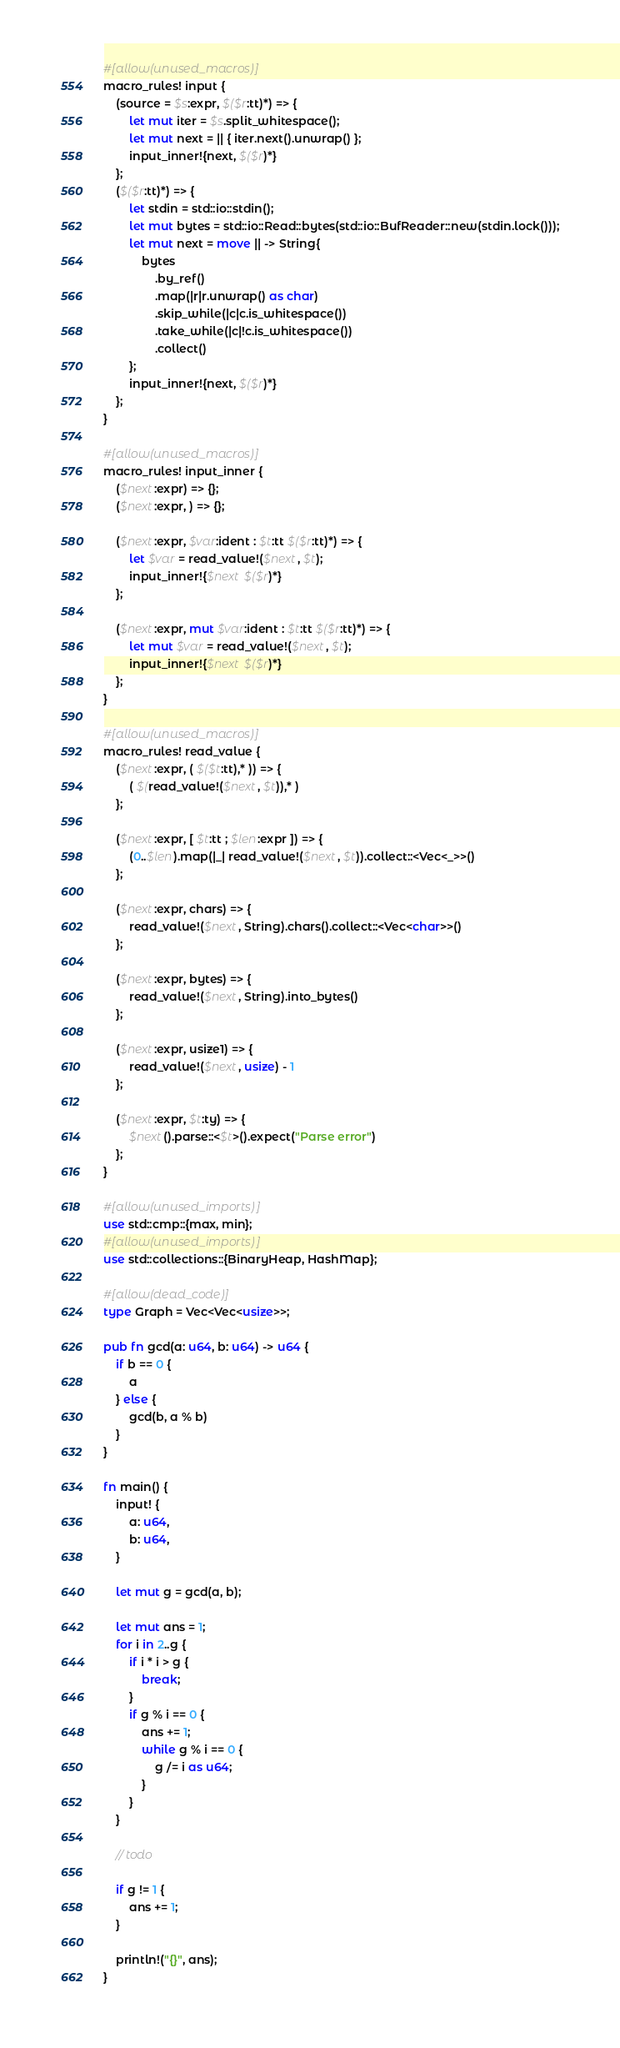Convert code to text. <code><loc_0><loc_0><loc_500><loc_500><_Rust_>#[allow(unused_macros)]
macro_rules! input {
    (source = $s:expr, $($r:tt)*) => {
        let mut iter = $s.split_whitespace();
        let mut next = || { iter.next().unwrap() };
        input_inner!{next, $($r)*}
    };
    ($($r:tt)*) => {
        let stdin = std::io::stdin();
        let mut bytes = std::io::Read::bytes(std::io::BufReader::new(stdin.lock()));
        let mut next = move || -> String{
            bytes
                .by_ref()
                .map(|r|r.unwrap() as char)
                .skip_while(|c|c.is_whitespace())
                .take_while(|c|!c.is_whitespace())
                .collect()
        };
        input_inner!{next, $($r)*}
    };
}

#[allow(unused_macros)]
macro_rules! input_inner {
    ($next:expr) => {};
    ($next:expr, ) => {};

    ($next:expr, $var:ident : $t:tt $($r:tt)*) => {
        let $var = read_value!($next, $t);
        input_inner!{$next $($r)*}
    };

    ($next:expr, mut $var:ident : $t:tt $($r:tt)*) => {
        let mut $var = read_value!($next, $t);
        input_inner!{$next $($r)*}
    };
}

#[allow(unused_macros)]
macro_rules! read_value {
    ($next:expr, ( $($t:tt),* )) => {
        ( $(read_value!($next, $t)),* )
    };

    ($next:expr, [ $t:tt ; $len:expr ]) => {
        (0..$len).map(|_| read_value!($next, $t)).collect::<Vec<_>>()
    };

    ($next:expr, chars) => {
        read_value!($next, String).chars().collect::<Vec<char>>()
    };

    ($next:expr, bytes) => {
        read_value!($next, String).into_bytes()
    };

    ($next:expr, usize1) => {
        read_value!($next, usize) - 1
    };

    ($next:expr, $t:ty) => {
        $next().parse::<$t>().expect("Parse error")
    };
}

#[allow(unused_imports)]
use std::cmp::{max, min};
#[allow(unused_imports)]
use std::collections::{BinaryHeap, HashMap};

#[allow(dead_code)]
type Graph = Vec<Vec<usize>>;

pub fn gcd(a: u64, b: u64) -> u64 {
    if b == 0 {
        a
    } else {
        gcd(b, a % b)
    }
}

fn main() {
    input! {
        a: u64,
        b: u64,
    }

    let mut g = gcd(a, b);

    let mut ans = 1;
    for i in 2..g {
        if i * i > g {
            break;
        }
        if g % i == 0 {
            ans += 1;
            while g % i == 0 {
                g /= i as u64;
            }
        }
    }

    // todo

    if g != 1 {
        ans += 1;
    }

    println!("{}", ans);
}
</code> 